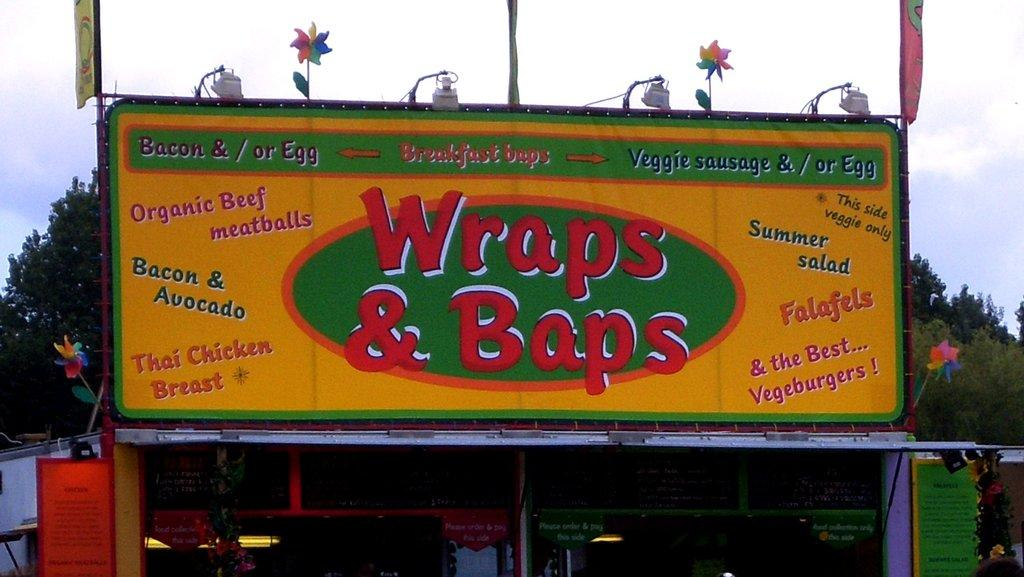<image>
Describe the image concisely. A small structure has a sign for Wraps and Baps above it, including various dishes that they serve on it. 